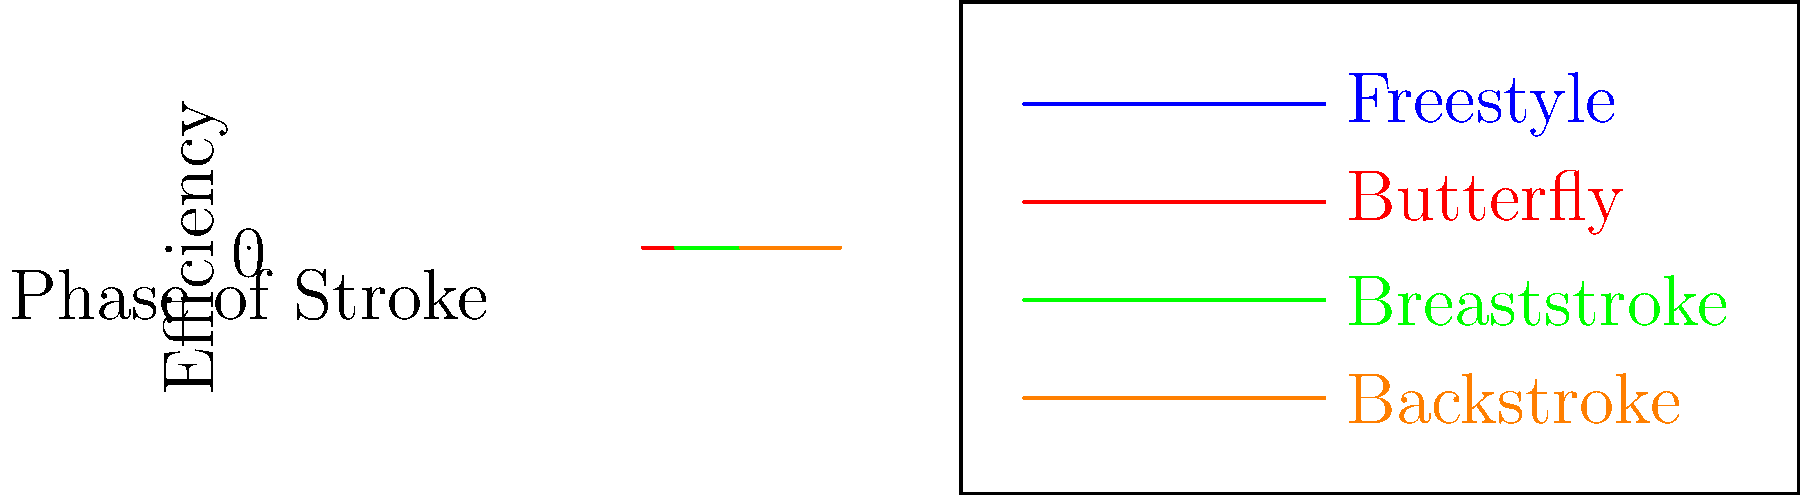Based on the graph showing the mechanical efficiency of various swimming strokes across different phases, which stroke demonstrates the highest peak efficiency and at which phase does this occur? How might this information influence training strategies for competitive swimmers? To answer this question, we need to analyze the graph step-by-step:

1. Identify the strokes: The graph shows four swimming strokes - Freestyle (blue), Butterfly (red), Breaststroke (green), and Backstroke (orange).

2. Understand the axes: The x-axis represents the phases of the stroke, while the y-axis represents efficiency.

3. Analyze peak efficiency:
   - Freestyle: Peak at approximately 0.9
   - Butterfly: Peak at approximately 0.85
   - Breaststroke: Peak at approximately 0.8
   - Backstroke: Peak at approximately 0.9

4. Determine the highest peak: Both Freestyle and Backstroke reach a peak of about 0.9, which is the highest among all strokes.

5. Identify the phase: The peak for both Freestyle and Backstroke occurs at the third phase of the stroke.

6. Training strategy implications:
   a) Focus on technique: Emphasize proper form during the most efficient phase to maximize overall performance.
   b) Stroke-specific training: Tailor training programs to improve efficiency in less efficient phases of each stroke.
   c) Energy management: Teach swimmers to conserve energy during less efficient phases and exert maximum effort during peak efficiency phases.
   d) Race strategy: Develop race plans that capitalize on the most efficient phases of the stroke, especially for sprint events.

This analysis provides valuable insights for coaches and swimmers to optimize performance and develop targeted training programs.
Answer: Freestyle and Backstroke; third phase. Implications: focus on technique, stroke-specific training, energy management, and race strategy optimization. 